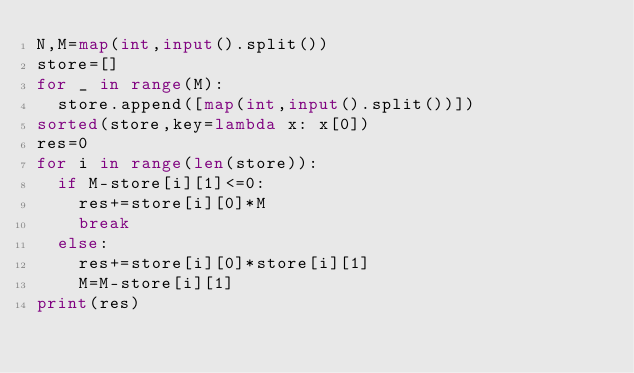Convert code to text. <code><loc_0><loc_0><loc_500><loc_500><_Python_>N,M=map(int,input().split())
store=[]
for _ in range(M):
  store.append([map(int,input().split())])
sorted(store,key=lambda x: x[0])
res=0
for i in range(len(store)):
  if M-store[i][1]<=0:
    res+=store[i][0]*M
    break
  else:
    res+=store[i][0]*store[i][1]
    M=M-store[i][1]
print(res)
</code> 